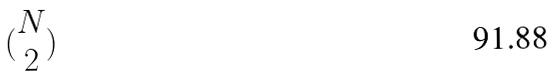Convert formula to latex. <formula><loc_0><loc_0><loc_500><loc_500>( \begin{matrix} N \\ 2 \end{matrix} )</formula> 